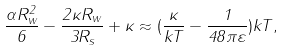Convert formula to latex. <formula><loc_0><loc_0><loc_500><loc_500>\frac { \alpha R _ { w } ^ { 2 } } { 6 } - \frac { 2 \kappa R _ { w } } { 3 R _ { s } } + \kappa \approx ( \frac { \kappa } { k T } - \frac { 1 } { 4 8 \pi \varepsilon } ) k T ,</formula> 